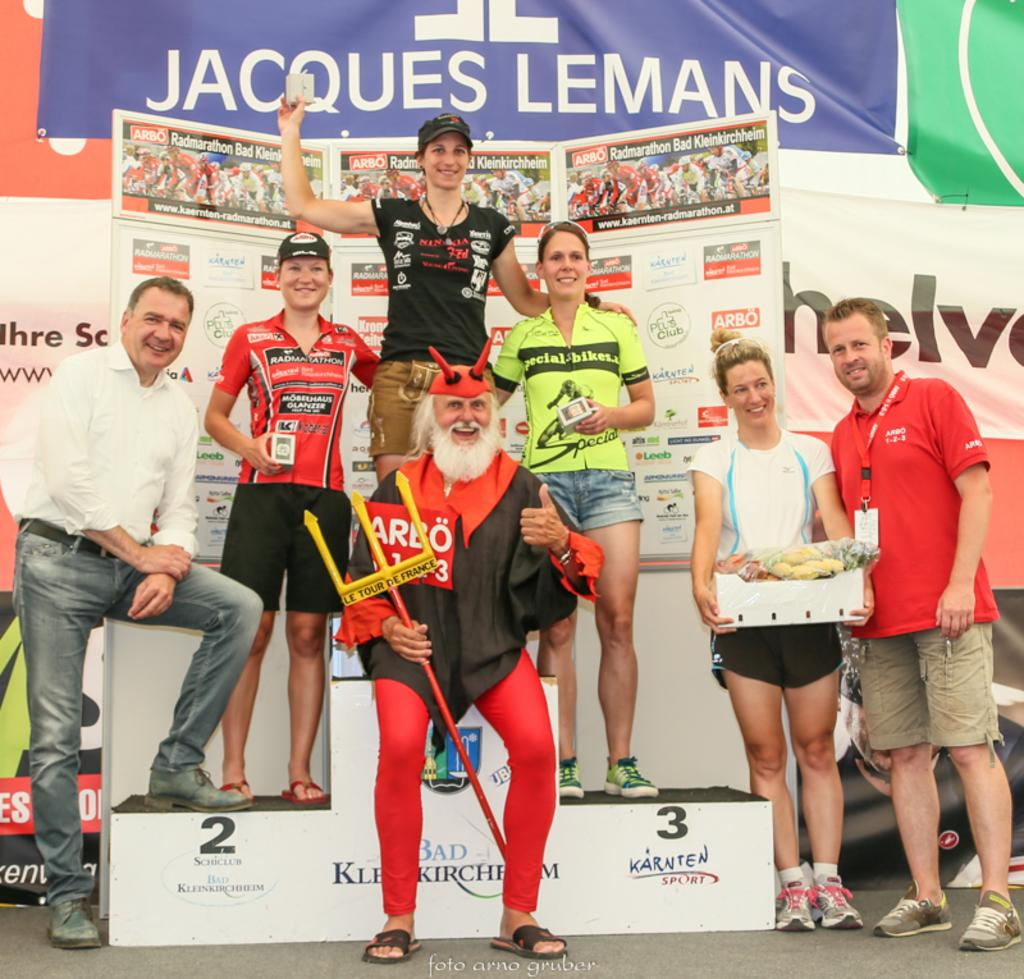<image>
Write a terse but informative summary of the picture. A man wearing a devil costume and holding a Tour de le France triton is standing in front of a podium. 